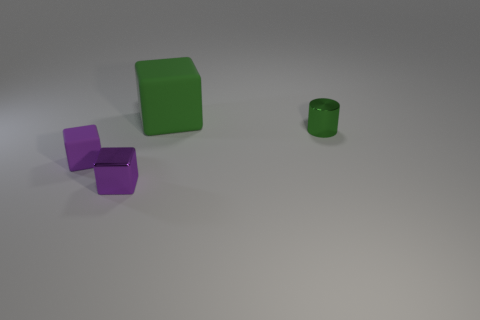Add 4 small purple metallic objects. How many objects exist? 8 Subtract all cylinders. How many objects are left? 3 Subtract 0 cyan cubes. How many objects are left? 4 Subtract all large green cubes. Subtract all tiny cylinders. How many objects are left? 2 Add 2 small matte things. How many small matte things are left? 3 Add 4 rubber things. How many rubber things exist? 6 